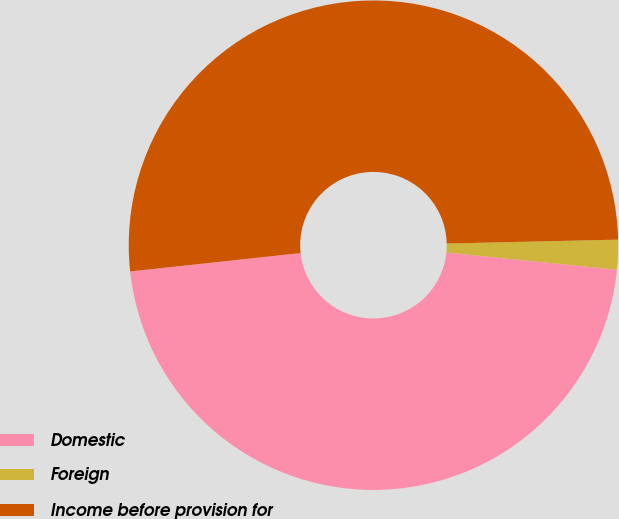Convert chart. <chart><loc_0><loc_0><loc_500><loc_500><pie_chart><fcel>Domestic<fcel>Foreign<fcel>Income before provision for<nl><fcel>46.69%<fcel>1.96%<fcel>51.35%<nl></chart> 